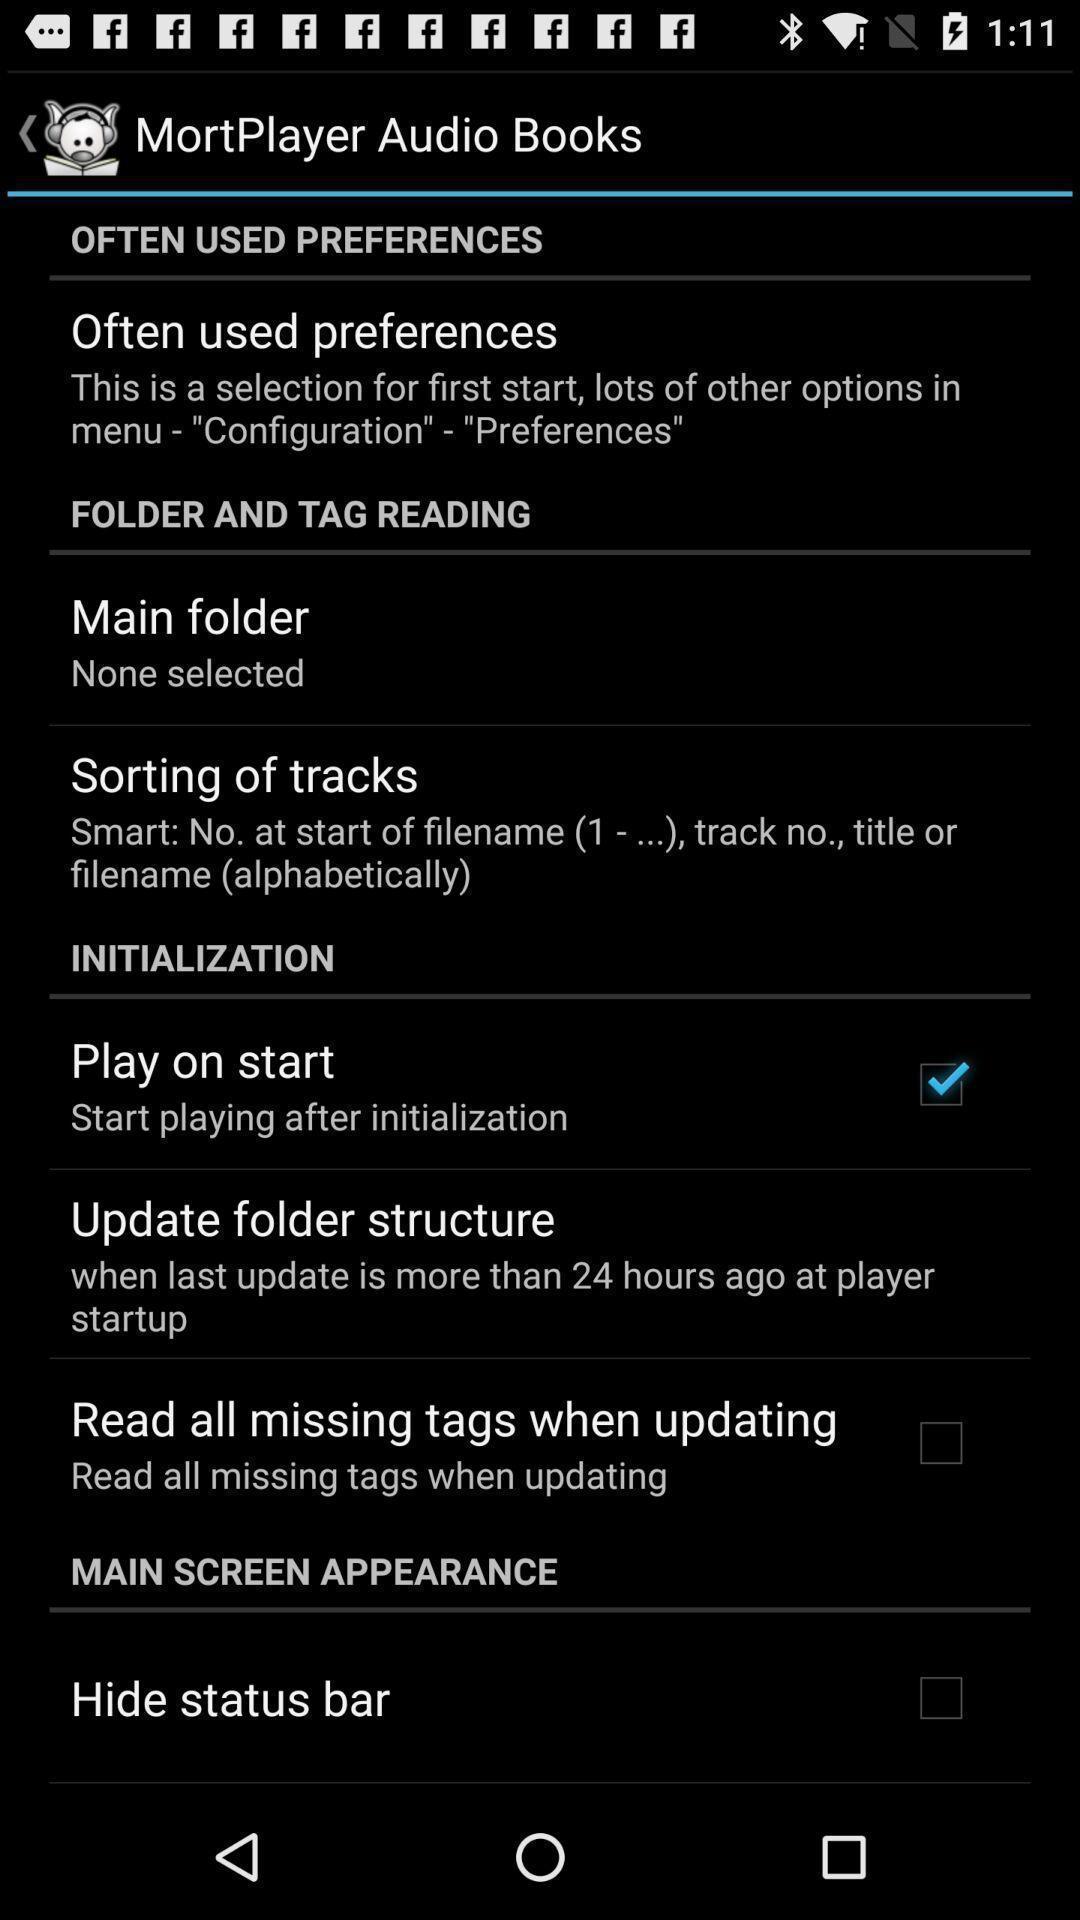What can you discern from this picture? Settings in a music player app. 